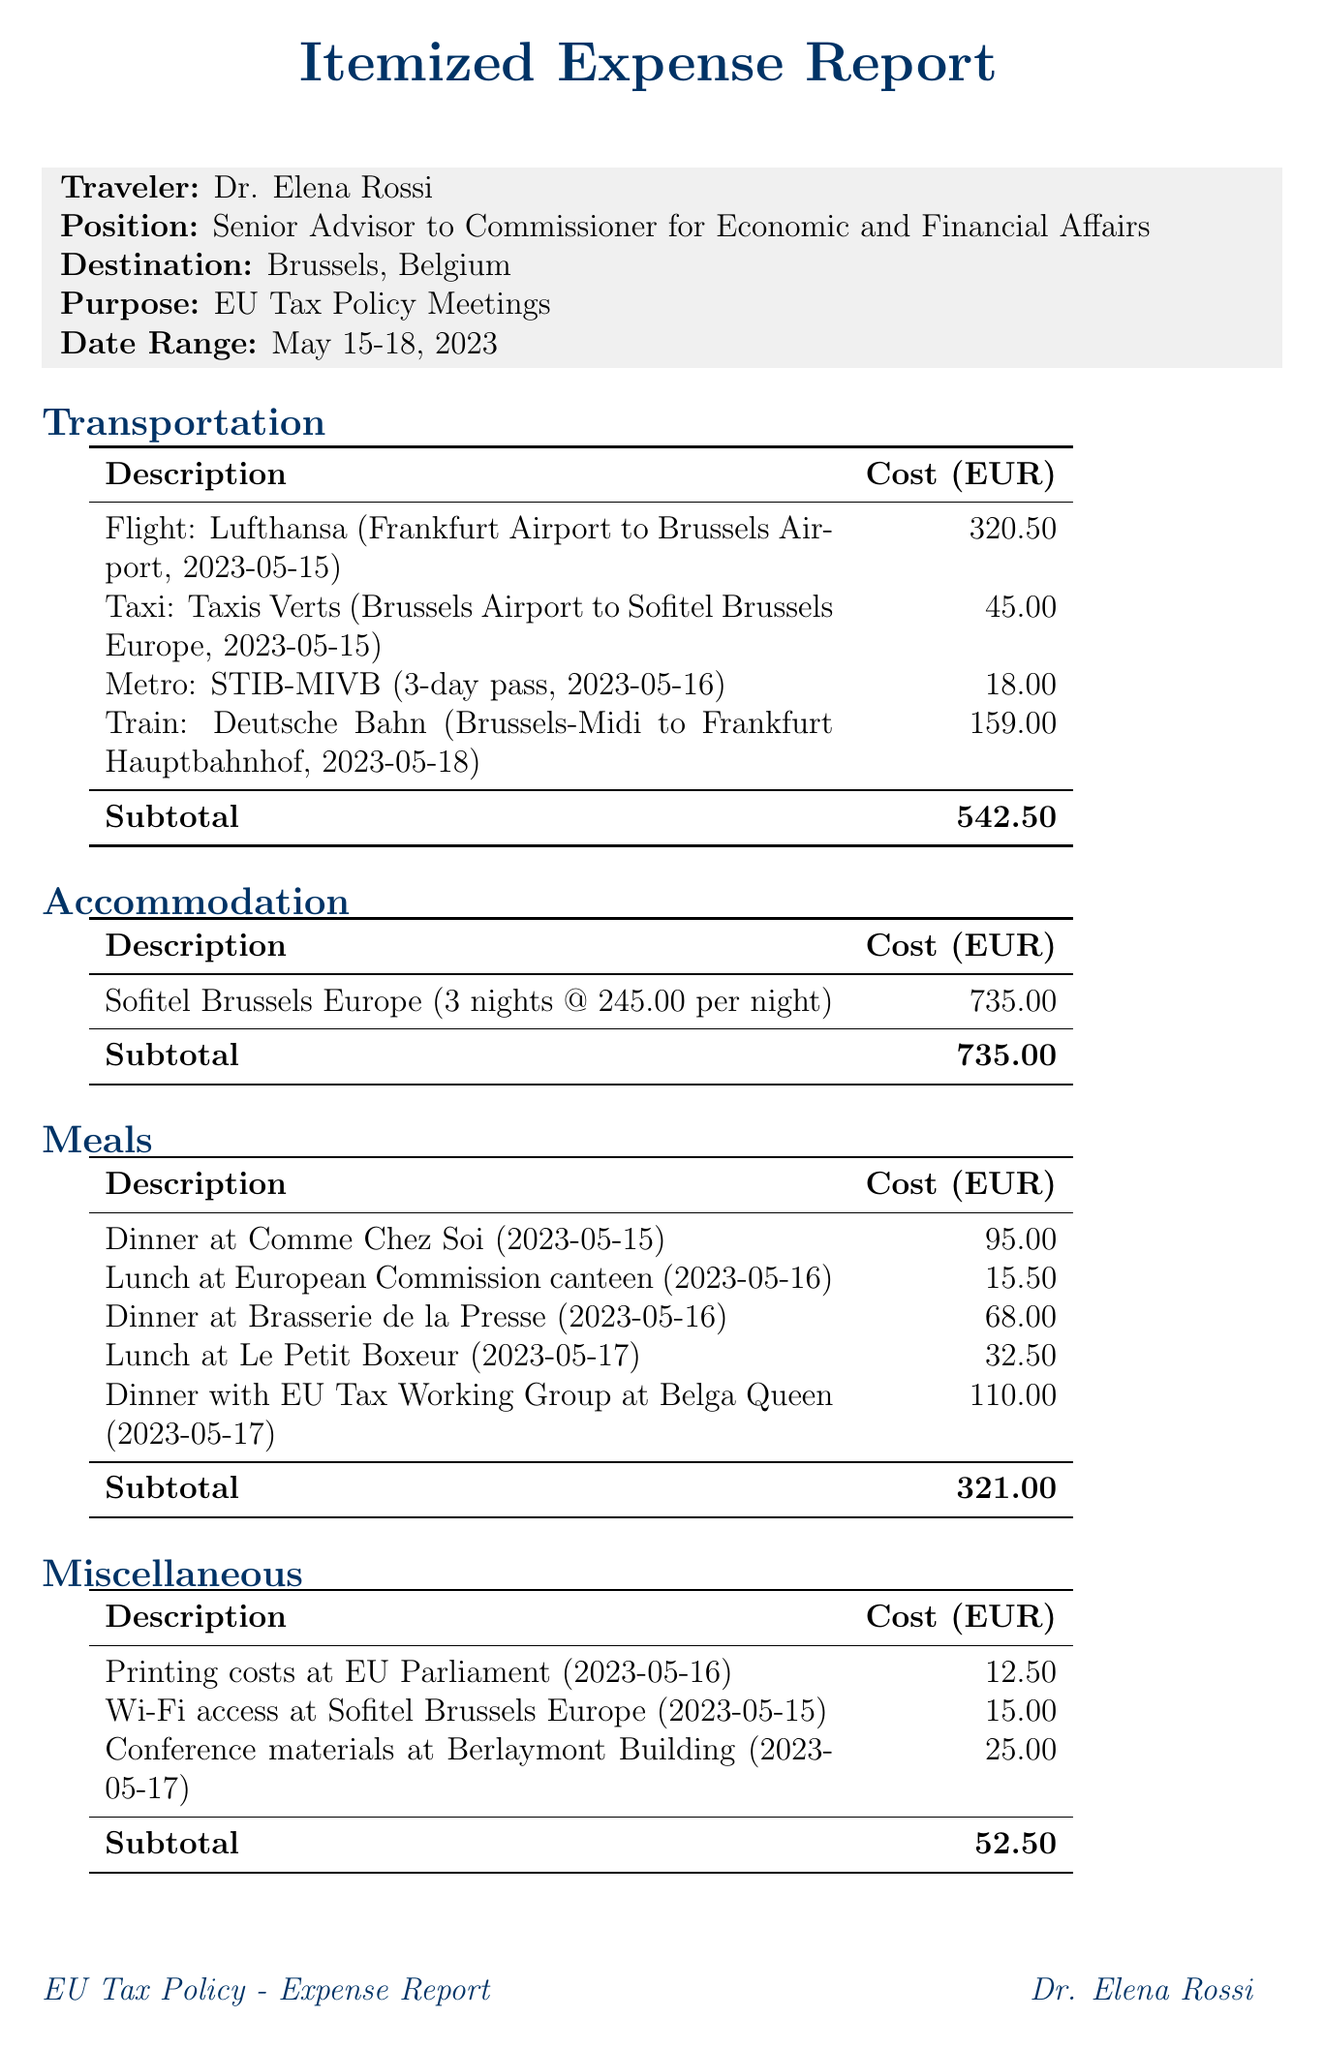What is the total cost of transportation? The total cost of transportation is listed as a subtotal in the document, which sums the individual transportation costs to EUR 542.50.
Answer: EUR 542.50 How many nights did Dr. Elena Rossi stay at the hotel? The number of nights stayed is mentioned in the accommodation section, which states 3 nights at Sofitel Brussels Europe.
Answer: 3 What date was the dinner at Comme Chez Soi? The date of the dinner at Comme Chez Soi is specified in the meals section of the document.
Answer: 2023-05-15 What is the cost of the printing costs at EU Parliament? This information is found in the miscellaneous section, which specifies the cost for printing costs on the mentioned date.
Answer: 12.50 How many meetings were held during the trip? The number of meetings can be derived from the meetings attended section, which lists them out.
Answer: 3 What was the cost per night for accommodation at the hotel? The cost per night is mentioned in the accommodation details, which indicates the rate charged for each night.
Answer: 245.00 What was the purpose of the trip? The purpose of the trip is stated clearly at the beginning of the document, identifying why Dr. Elena Rossi traveled.
Answer: EU Tax Policy Meetings Which provider operated the flight from Frankfurt to Brussels? The flight provider is listed under the transportation section, identifying who operated the flight.
Answer: Lufthansa What is the total expense amount? The total expense amount is summed up at the end of the document, compiling all costs incurred during the trip.
Answer: EUR 1,651.00 